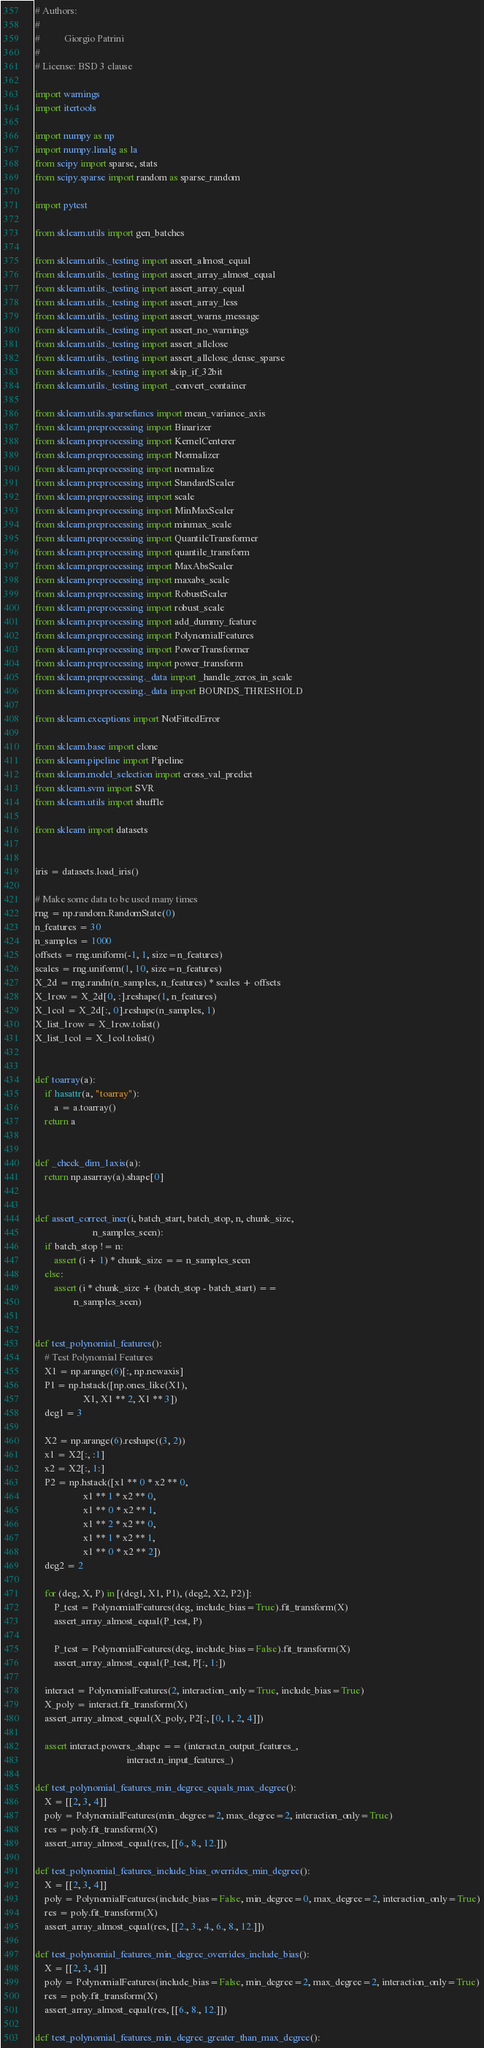Convert code to text. <code><loc_0><loc_0><loc_500><loc_500><_Python_># Authors:
#
#          Giorgio Patrini
#
# License: BSD 3 clause

import warnings
import itertools

import numpy as np
import numpy.linalg as la
from scipy import sparse, stats
from scipy.sparse import random as sparse_random

import pytest

from sklearn.utils import gen_batches

from sklearn.utils._testing import assert_almost_equal
from sklearn.utils._testing import assert_array_almost_equal
from sklearn.utils._testing import assert_array_equal
from sklearn.utils._testing import assert_array_less
from sklearn.utils._testing import assert_warns_message
from sklearn.utils._testing import assert_no_warnings
from sklearn.utils._testing import assert_allclose
from sklearn.utils._testing import assert_allclose_dense_sparse
from sklearn.utils._testing import skip_if_32bit
from sklearn.utils._testing import _convert_container

from sklearn.utils.sparsefuncs import mean_variance_axis
from sklearn.preprocessing import Binarizer
from sklearn.preprocessing import KernelCenterer
from sklearn.preprocessing import Normalizer
from sklearn.preprocessing import normalize
from sklearn.preprocessing import StandardScaler
from sklearn.preprocessing import scale
from sklearn.preprocessing import MinMaxScaler
from sklearn.preprocessing import minmax_scale
from sklearn.preprocessing import QuantileTransformer
from sklearn.preprocessing import quantile_transform
from sklearn.preprocessing import MaxAbsScaler
from sklearn.preprocessing import maxabs_scale
from sklearn.preprocessing import RobustScaler
from sklearn.preprocessing import robust_scale
from sklearn.preprocessing import add_dummy_feature
from sklearn.preprocessing import PolynomialFeatures
from sklearn.preprocessing import PowerTransformer
from sklearn.preprocessing import power_transform
from sklearn.preprocessing._data import _handle_zeros_in_scale
from sklearn.preprocessing._data import BOUNDS_THRESHOLD

from sklearn.exceptions import NotFittedError

from sklearn.base import clone
from sklearn.pipeline import Pipeline
from sklearn.model_selection import cross_val_predict
from sklearn.svm import SVR
from sklearn.utils import shuffle

from sklearn import datasets


iris = datasets.load_iris()

# Make some data to be used many times
rng = np.random.RandomState(0)
n_features = 30
n_samples = 1000
offsets = rng.uniform(-1, 1, size=n_features)
scales = rng.uniform(1, 10, size=n_features)
X_2d = rng.randn(n_samples, n_features) * scales + offsets
X_1row = X_2d[0, :].reshape(1, n_features)
X_1col = X_2d[:, 0].reshape(n_samples, 1)
X_list_1row = X_1row.tolist()
X_list_1col = X_1col.tolist()


def toarray(a):
    if hasattr(a, "toarray"):
        a = a.toarray()
    return a


def _check_dim_1axis(a):
    return np.asarray(a).shape[0]


def assert_correct_incr(i, batch_start, batch_stop, n, chunk_size,
                        n_samples_seen):
    if batch_stop != n:
        assert (i + 1) * chunk_size == n_samples_seen
    else:
        assert (i * chunk_size + (batch_stop - batch_start) ==
                n_samples_seen)


def test_polynomial_features():
    # Test Polynomial Features
    X1 = np.arange(6)[:, np.newaxis]
    P1 = np.hstack([np.ones_like(X1),
                    X1, X1 ** 2, X1 ** 3])
    deg1 = 3

    X2 = np.arange(6).reshape((3, 2))
    x1 = X2[:, :1]
    x2 = X2[:, 1:]
    P2 = np.hstack([x1 ** 0 * x2 ** 0,
                    x1 ** 1 * x2 ** 0,
                    x1 ** 0 * x2 ** 1,
                    x1 ** 2 * x2 ** 0,
                    x1 ** 1 * x2 ** 1,
                    x1 ** 0 * x2 ** 2])
    deg2 = 2

    for (deg, X, P) in [(deg1, X1, P1), (deg2, X2, P2)]:
        P_test = PolynomialFeatures(deg, include_bias=True).fit_transform(X)
        assert_array_almost_equal(P_test, P)

        P_test = PolynomialFeatures(deg, include_bias=False).fit_transform(X)
        assert_array_almost_equal(P_test, P[:, 1:])

    interact = PolynomialFeatures(2, interaction_only=True, include_bias=True)
    X_poly = interact.fit_transform(X)
    assert_array_almost_equal(X_poly, P2[:, [0, 1, 2, 4]])

    assert interact.powers_.shape == (interact.n_output_features_,
                                      interact.n_input_features_)

def test_polynomial_features_min_degree_equals_max_degree():
    X = [[2, 3, 4]]
    poly = PolynomialFeatures(min_degree=2, max_degree=2, interaction_only=True)
    res = poly.fit_transform(X)
    assert_array_almost_equal(res, [[6., 8., 12.]])

def test_polynomial_features_include_bias_overrides_min_degree():
    X = [[2, 3, 4]]
    poly = PolynomialFeatures(include_bias=False, min_degree=0, max_degree=2, interaction_only=True)
    res = poly.fit_transform(X)
    assert_array_almost_equal(res, [[2., 3., 4., 6., 8., 12.]])

def test_polynomial_features_min_degree_overrides_include_bias():
    X = [[2, 3, 4]]
    poly = PolynomialFeatures(include_bias=False, min_degree=2, max_degree=2, interaction_only=True)
    res = poly.fit_transform(X)
    assert_array_almost_equal(res, [[6., 8., 12.]])

def test_polynomial_features_min_degree_greater_than_max_degree():</code> 